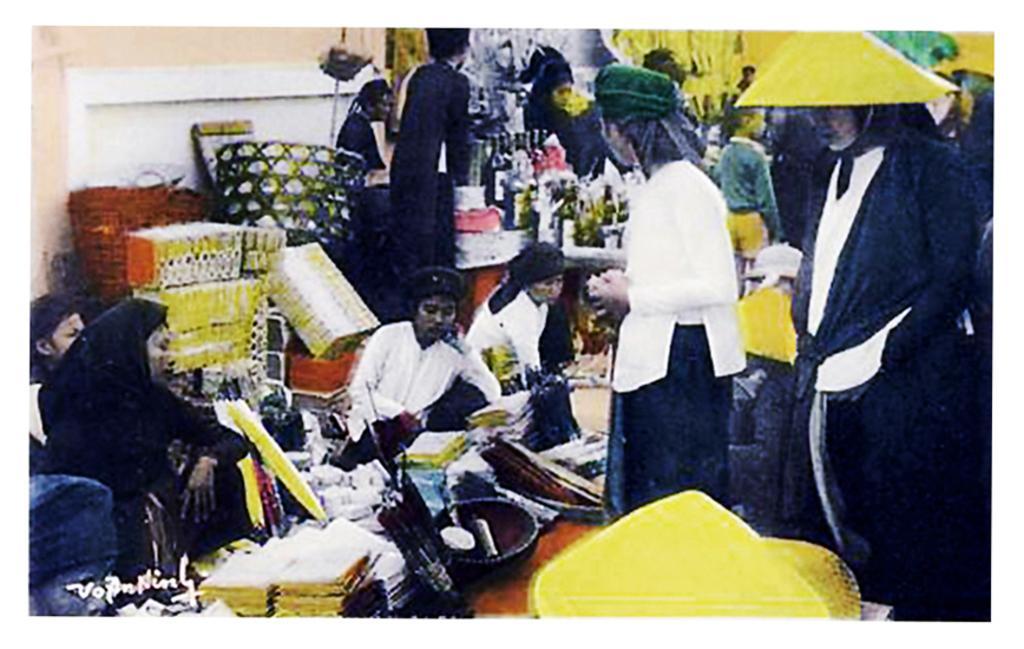Can you describe this image briefly? This picture describes about group of people, few are sitting and few are standing, in front of them we can see boxes, bottles, basket and other things, in the bottom left hand corner we can see some text. 